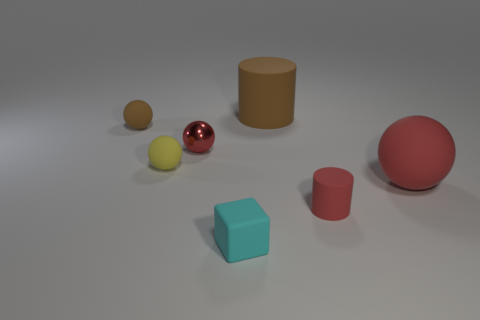Subtract 1 balls. How many balls are left? 3 Add 1 small red spheres. How many objects exist? 8 Subtract all purple spheres. Subtract all blue cubes. How many spheres are left? 4 Subtract all spheres. How many objects are left? 3 Add 1 tiny brown metal blocks. How many tiny brown metal blocks exist? 1 Subtract 0 gray cylinders. How many objects are left? 7 Subtract all red matte spheres. Subtract all cyan cubes. How many objects are left? 5 Add 4 large red spheres. How many large red spheres are left? 5 